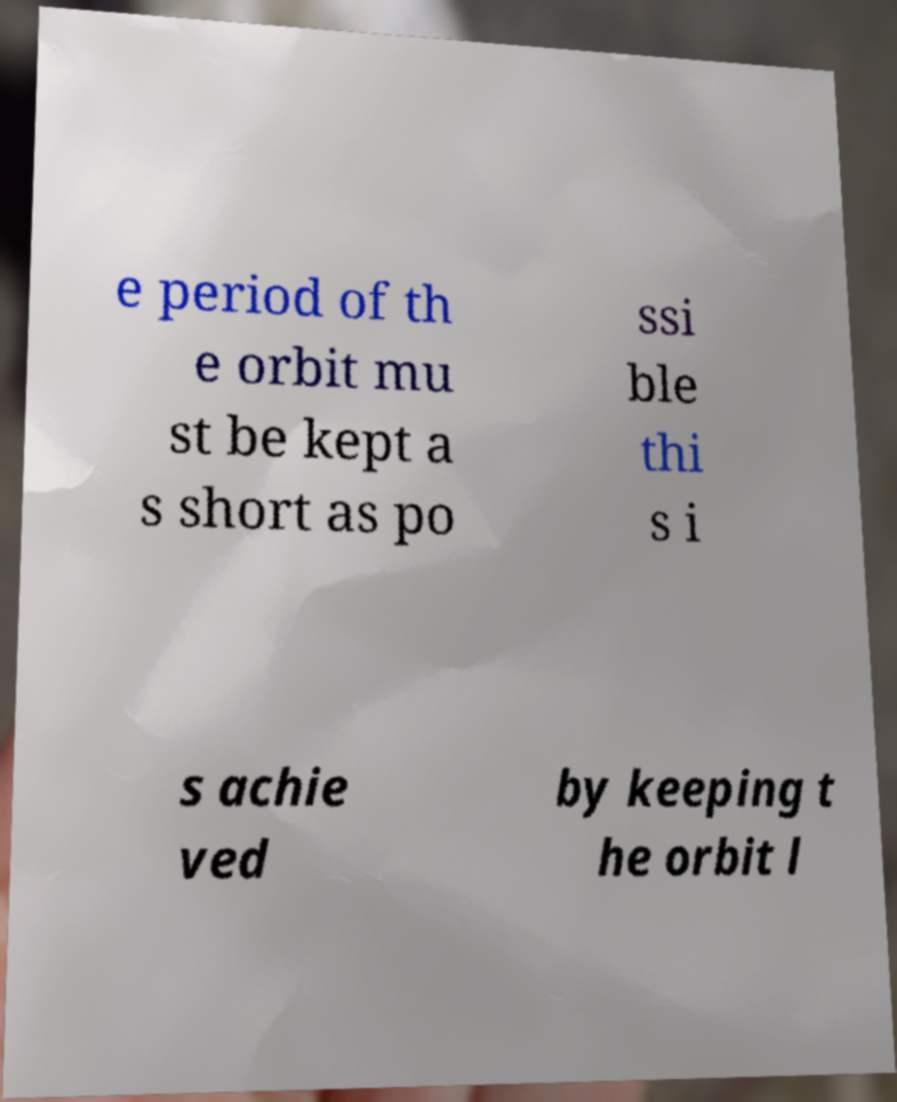I need the written content from this picture converted into text. Can you do that? e period of th e orbit mu st be kept a s short as po ssi ble thi s i s achie ved by keeping t he orbit l 